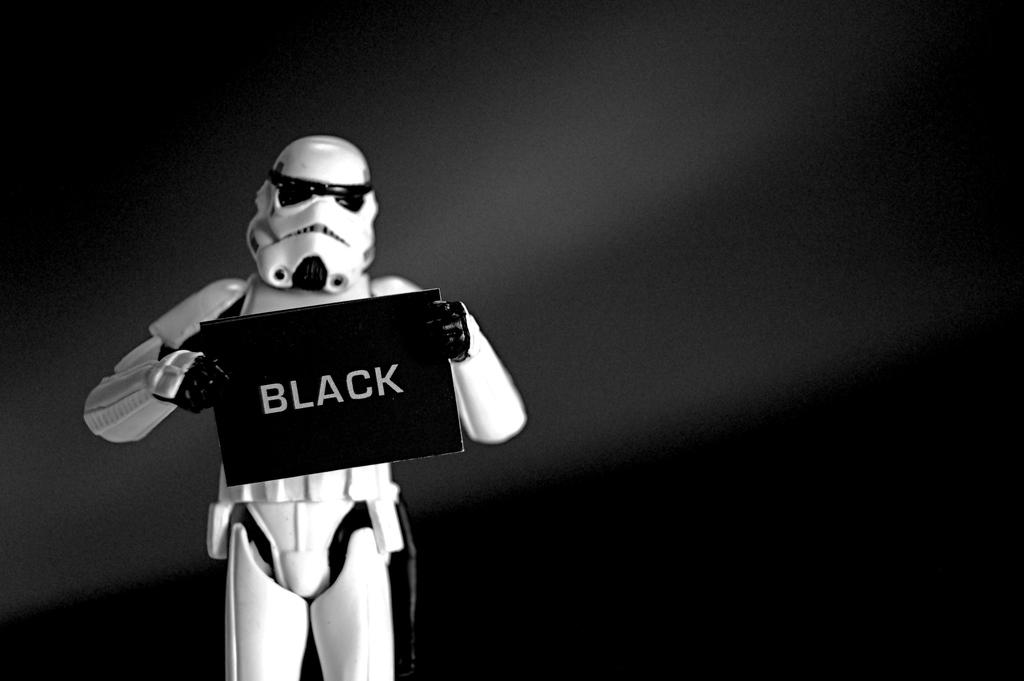What is the main subject in the foreground of the image? There is a robot in the foreground of the image. What is the robot holding in its hands? The robot is holding a board. What can be seen in the background of the image? There is a wall in the background of the image. Can you tell me how many rabbits are sitting next to the robot in the image? There are no rabbits present in the image; the main subject is a robot holding a board. 